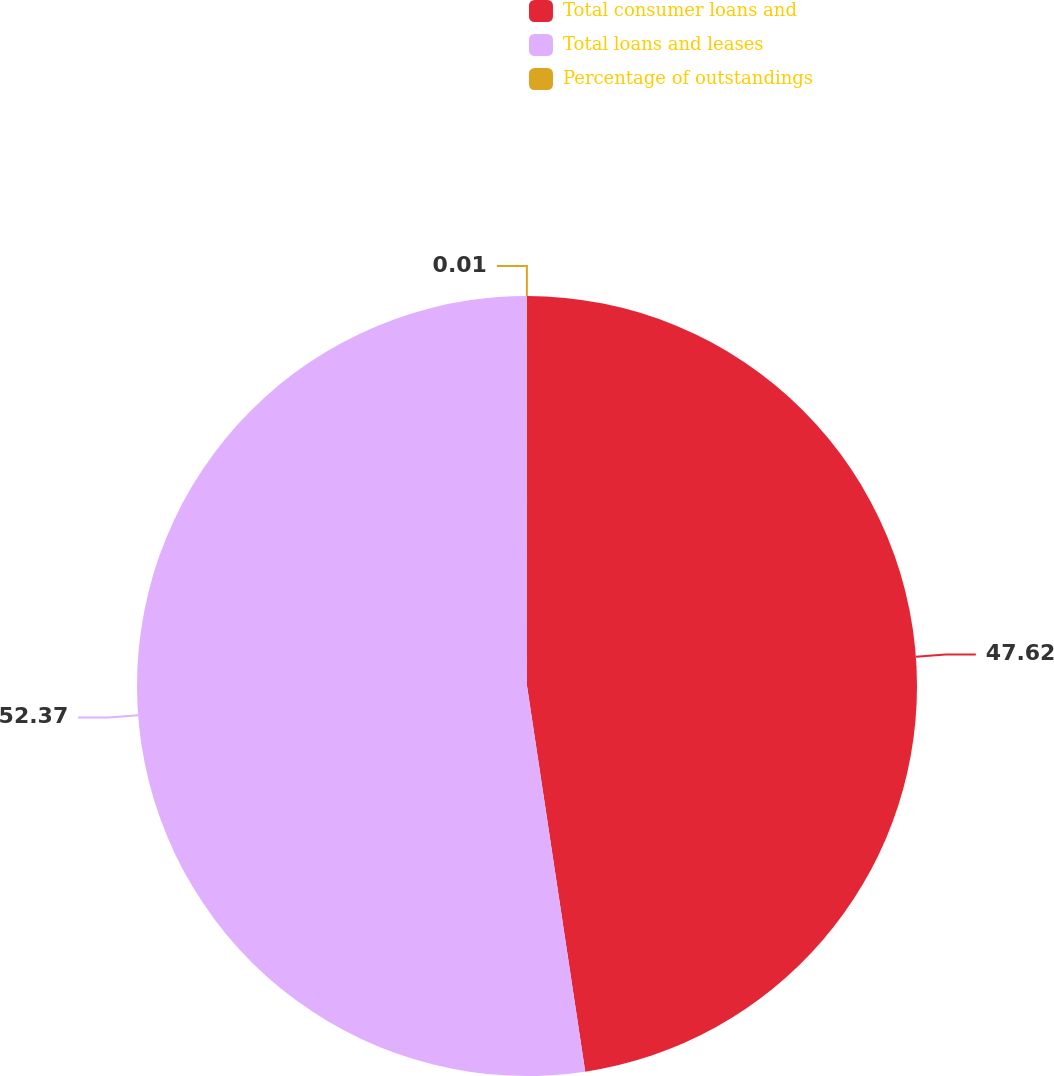Convert chart to OTSL. <chart><loc_0><loc_0><loc_500><loc_500><pie_chart><fcel>Total consumer loans and<fcel>Total loans and leases<fcel>Percentage of outstandings<nl><fcel>47.62%<fcel>52.38%<fcel>0.01%<nl></chart> 